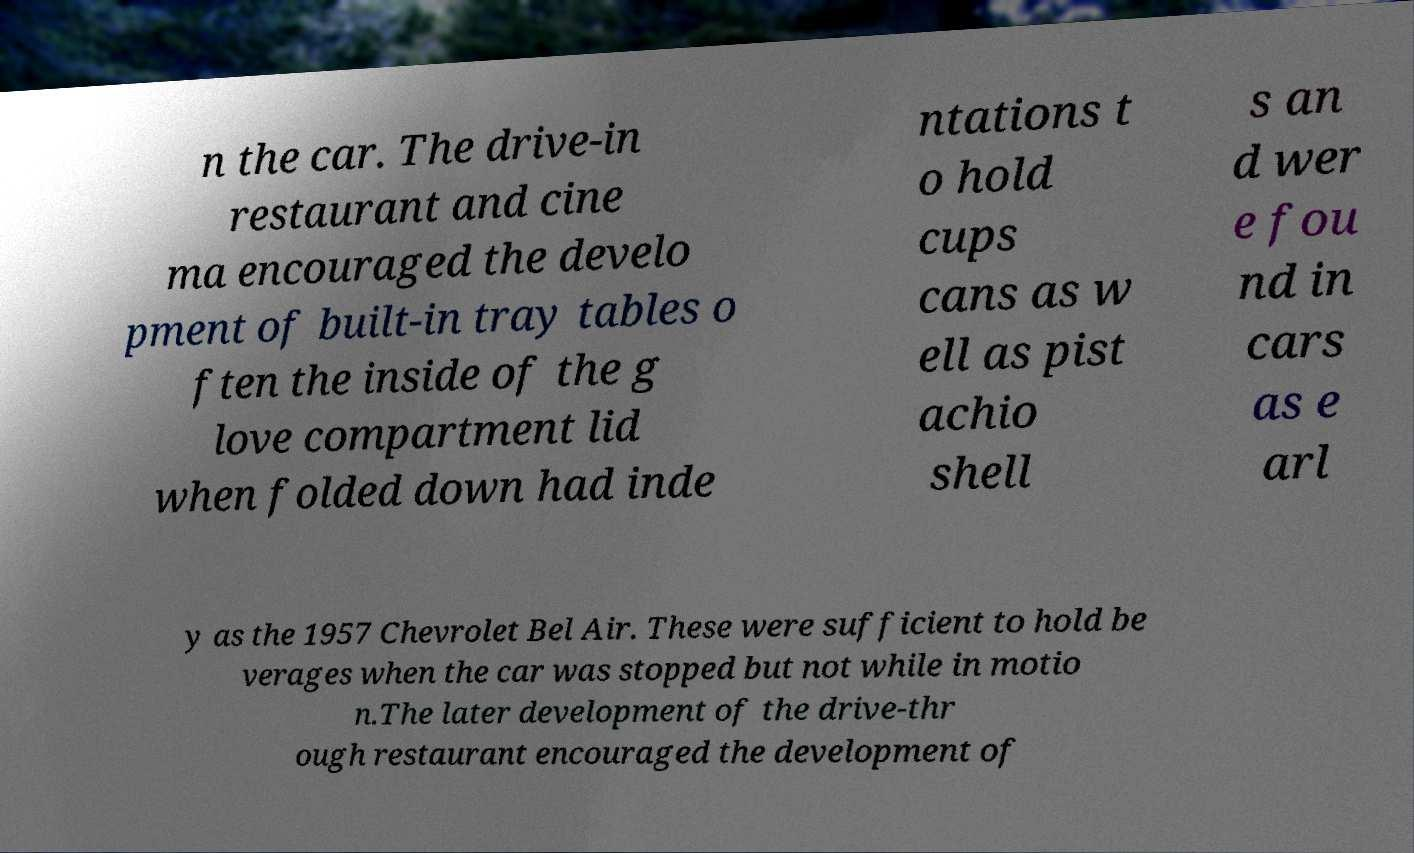Could you extract and type out the text from this image? n the car. The drive-in restaurant and cine ma encouraged the develo pment of built-in tray tables o ften the inside of the g love compartment lid when folded down had inde ntations t o hold cups cans as w ell as pist achio shell s an d wer e fou nd in cars as e arl y as the 1957 Chevrolet Bel Air. These were sufficient to hold be verages when the car was stopped but not while in motio n.The later development of the drive-thr ough restaurant encouraged the development of 